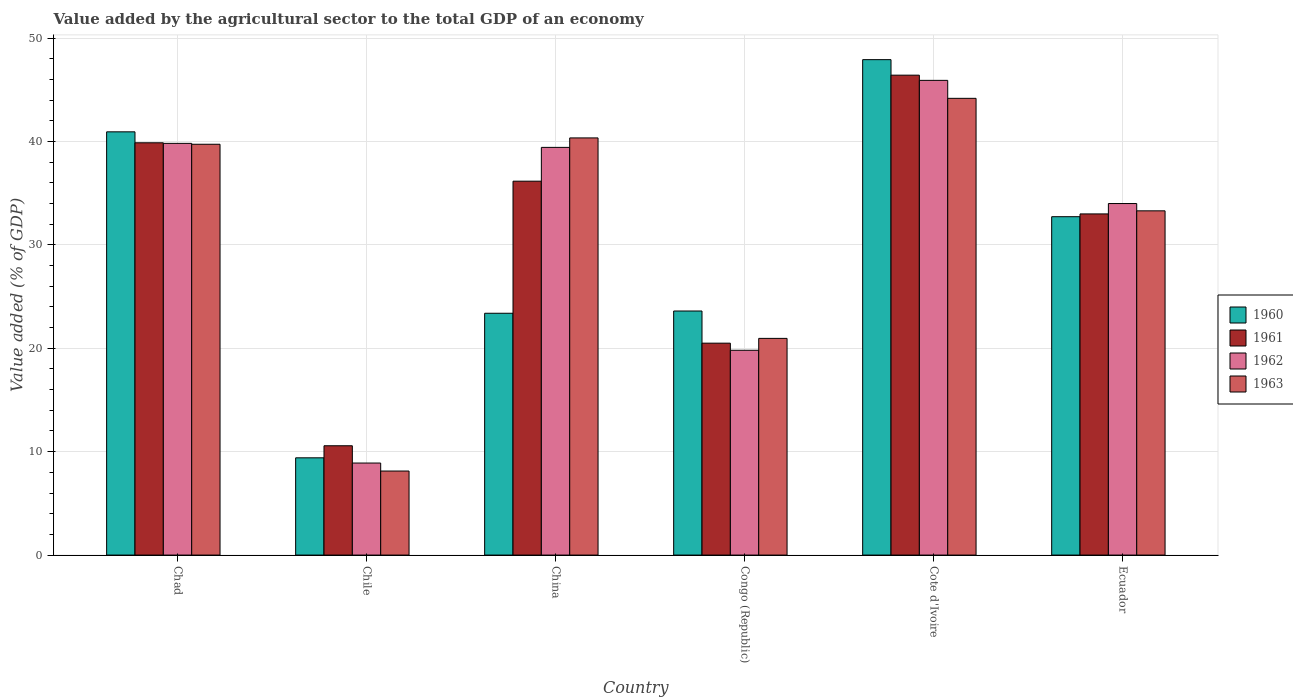How many different coloured bars are there?
Keep it short and to the point. 4. Are the number of bars on each tick of the X-axis equal?
Provide a succinct answer. Yes. How many bars are there on the 1st tick from the left?
Keep it short and to the point. 4. What is the label of the 2nd group of bars from the left?
Offer a terse response. Chile. What is the value added by the agricultural sector to the total GDP in 1963 in Chile?
Your response must be concise. 8.13. Across all countries, what is the maximum value added by the agricultural sector to the total GDP in 1962?
Keep it short and to the point. 45.9. Across all countries, what is the minimum value added by the agricultural sector to the total GDP in 1961?
Your answer should be very brief. 10.57. In which country was the value added by the agricultural sector to the total GDP in 1962 maximum?
Ensure brevity in your answer.  Cote d'Ivoire. In which country was the value added by the agricultural sector to the total GDP in 1960 minimum?
Provide a succinct answer. Chile. What is the total value added by the agricultural sector to the total GDP in 1961 in the graph?
Make the answer very short. 186.48. What is the difference between the value added by the agricultural sector to the total GDP in 1963 in China and that in Ecuador?
Provide a succinct answer. 7.05. What is the difference between the value added by the agricultural sector to the total GDP in 1962 in Chile and the value added by the agricultural sector to the total GDP in 1963 in Cote d'Ivoire?
Provide a short and direct response. -35.27. What is the average value added by the agricultural sector to the total GDP in 1960 per country?
Your answer should be very brief. 29.66. What is the difference between the value added by the agricultural sector to the total GDP of/in 1963 and value added by the agricultural sector to the total GDP of/in 1961 in Chad?
Ensure brevity in your answer.  -0.14. What is the ratio of the value added by the agricultural sector to the total GDP in 1963 in China to that in Ecuador?
Your answer should be compact. 1.21. What is the difference between the highest and the second highest value added by the agricultural sector to the total GDP in 1963?
Ensure brevity in your answer.  -3.83. What is the difference between the highest and the lowest value added by the agricultural sector to the total GDP in 1962?
Provide a succinct answer. 37. In how many countries, is the value added by the agricultural sector to the total GDP in 1963 greater than the average value added by the agricultural sector to the total GDP in 1963 taken over all countries?
Offer a terse response. 4. Is the sum of the value added by the agricultural sector to the total GDP in 1962 in Congo (Republic) and Ecuador greater than the maximum value added by the agricultural sector to the total GDP in 1961 across all countries?
Your response must be concise. Yes. Is it the case that in every country, the sum of the value added by the agricultural sector to the total GDP in 1961 and value added by the agricultural sector to the total GDP in 1960 is greater than the sum of value added by the agricultural sector to the total GDP in 1962 and value added by the agricultural sector to the total GDP in 1963?
Give a very brief answer. No. What does the 4th bar from the left in Ecuador represents?
Provide a short and direct response. 1963. What does the 4th bar from the right in Chile represents?
Ensure brevity in your answer.  1960. Is it the case that in every country, the sum of the value added by the agricultural sector to the total GDP in 1963 and value added by the agricultural sector to the total GDP in 1962 is greater than the value added by the agricultural sector to the total GDP in 1961?
Make the answer very short. Yes. How many bars are there?
Provide a short and direct response. 24. How many countries are there in the graph?
Offer a very short reply. 6. What is the difference between two consecutive major ticks on the Y-axis?
Offer a very short reply. 10. Does the graph contain grids?
Offer a very short reply. Yes. Where does the legend appear in the graph?
Offer a terse response. Center right. How many legend labels are there?
Give a very brief answer. 4. How are the legend labels stacked?
Provide a short and direct response. Vertical. What is the title of the graph?
Your answer should be very brief. Value added by the agricultural sector to the total GDP of an economy. Does "2010" appear as one of the legend labels in the graph?
Your response must be concise. No. What is the label or title of the Y-axis?
Your answer should be compact. Value added (% of GDP). What is the Value added (% of GDP) in 1960 in Chad?
Ensure brevity in your answer.  40.93. What is the Value added (% of GDP) of 1961 in Chad?
Offer a very short reply. 39.87. What is the Value added (% of GDP) of 1962 in Chad?
Provide a short and direct response. 39.81. What is the Value added (% of GDP) in 1963 in Chad?
Offer a terse response. 39.73. What is the Value added (% of GDP) in 1960 in Chile?
Provide a succinct answer. 9.4. What is the Value added (% of GDP) in 1961 in Chile?
Keep it short and to the point. 10.57. What is the Value added (% of GDP) of 1962 in Chile?
Provide a short and direct response. 8.9. What is the Value added (% of GDP) of 1963 in Chile?
Ensure brevity in your answer.  8.13. What is the Value added (% of GDP) in 1960 in China?
Ensure brevity in your answer.  23.38. What is the Value added (% of GDP) in 1961 in China?
Keep it short and to the point. 36.16. What is the Value added (% of GDP) in 1962 in China?
Provide a succinct answer. 39.42. What is the Value added (% of GDP) of 1963 in China?
Your answer should be very brief. 40.34. What is the Value added (% of GDP) in 1960 in Congo (Republic)?
Your response must be concise. 23.6. What is the Value added (% of GDP) of 1961 in Congo (Republic)?
Ensure brevity in your answer.  20.49. What is the Value added (% of GDP) of 1962 in Congo (Republic)?
Your response must be concise. 19.8. What is the Value added (% of GDP) of 1963 in Congo (Republic)?
Your response must be concise. 20.95. What is the Value added (% of GDP) of 1960 in Cote d'Ivoire?
Your answer should be compact. 47.91. What is the Value added (% of GDP) of 1961 in Cote d'Ivoire?
Keep it short and to the point. 46.41. What is the Value added (% of GDP) in 1962 in Cote d'Ivoire?
Give a very brief answer. 45.9. What is the Value added (% of GDP) of 1963 in Cote d'Ivoire?
Your answer should be very brief. 44.17. What is the Value added (% of GDP) in 1960 in Ecuador?
Provide a succinct answer. 32.72. What is the Value added (% of GDP) of 1961 in Ecuador?
Ensure brevity in your answer.  32.99. What is the Value added (% of GDP) of 1962 in Ecuador?
Give a very brief answer. 33.99. What is the Value added (% of GDP) in 1963 in Ecuador?
Your answer should be compact. 33.29. Across all countries, what is the maximum Value added (% of GDP) of 1960?
Provide a succinct answer. 47.91. Across all countries, what is the maximum Value added (% of GDP) in 1961?
Your answer should be very brief. 46.41. Across all countries, what is the maximum Value added (% of GDP) of 1962?
Your answer should be very brief. 45.9. Across all countries, what is the maximum Value added (% of GDP) of 1963?
Make the answer very short. 44.17. Across all countries, what is the minimum Value added (% of GDP) of 1960?
Offer a terse response. 9.4. Across all countries, what is the minimum Value added (% of GDP) of 1961?
Make the answer very short. 10.57. Across all countries, what is the minimum Value added (% of GDP) of 1962?
Make the answer very short. 8.9. Across all countries, what is the minimum Value added (% of GDP) in 1963?
Your answer should be compact. 8.13. What is the total Value added (% of GDP) of 1960 in the graph?
Your response must be concise. 177.94. What is the total Value added (% of GDP) of 1961 in the graph?
Your response must be concise. 186.48. What is the total Value added (% of GDP) of 1962 in the graph?
Keep it short and to the point. 187.84. What is the total Value added (% of GDP) of 1963 in the graph?
Give a very brief answer. 186.6. What is the difference between the Value added (% of GDP) in 1960 in Chad and that in Chile?
Offer a terse response. 31.52. What is the difference between the Value added (% of GDP) of 1961 in Chad and that in Chile?
Provide a short and direct response. 29.3. What is the difference between the Value added (% of GDP) in 1962 in Chad and that in Chile?
Make the answer very short. 30.91. What is the difference between the Value added (% of GDP) of 1963 in Chad and that in Chile?
Your answer should be compact. 31.6. What is the difference between the Value added (% of GDP) in 1960 in Chad and that in China?
Keep it short and to the point. 17.54. What is the difference between the Value added (% of GDP) in 1961 in Chad and that in China?
Provide a succinct answer. 3.71. What is the difference between the Value added (% of GDP) of 1962 in Chad and that in China?
Your response must be concise. 0.39. What is the difference between the Value added (% of GDP) of 1963 in Chad and that in China?
Keep it short and to the point. -0.61. What is the difference between the Value added (% of GDP) of 1960 in Chad and that in Congo (Republic)?
Offer a terse response. 17.33. What is the difference between the Value added (% of GDP) in 1961 in Chad and that in Congo (Republic)?
Your answer should be compact. 19.38. What is the difference between the Value added (% of GDP) of 1962 in Chad and that in Congo (Republic)?
Your answer should be very brief. 20.01. What is the difference between the Value added (% of GDP) of 1963 in Chad and that in Congo (Republic)?
Your response must be concise. 18.77. What is the difference between the Value added (% of GDP) in 1960 in Chad and that in Cote d'Ivoire?
Provide a succinct answer. -6.98. What is the difference between the Value added (% of GDP) in 1961 in Chad and that in Cote d'Ivoire?
Your response must be concise. -6.54. What is the difference between the Value added (% of GDP) of 1962 in Chad and that in Cote d'Ivoire?
Offer a very short reply. -6.09. What is the difference between the Value added (% of GDP) of 1963 in Chad and that in Cote d'Ivoire?
Your answer should be very brief. -4.44. What is the difference between the Value added (% of GDP) of 1960 in Chad and that in Ecuador?
Provide a succinct answer. 8.21. What is the difference between the Value added (% of GDP) in 1961 in Chad and that in Ecuador?
Offer a terse response. 6.88. What is the difference between the Value added (% of GDP) of 1962 in Chad and that in Ecuador?
Your answer should be compact. 5.82. What is the difference between the Value added (% of GDP) of 1963 in Chad and that in Ecuador?
Your response must be concise. 6.44. What is the difference between the Value added (% of GDP) in 1960 in Chile and that in China?
Make the answer very short. -13.98. What is the difference between the Value added (% of GDP) in 1961 in Chile and that in China?
Your response must be concise. -25.58. What is the difference between the Value added (% of GDP) in 1962 in Chile and that in China?
Offer a very short reply. -30.52. What is the difference between the Value added (% of GDP) in 1963 in Chile and that in China?
Provide a short and direct response. -32.21. What is the difference between the Value added (% of GDP) in 1960 in Chile and that in Congo (Republic)?
Keep it short and to the point. -14.2. What is the difference between the Value added (% of GDP) in 1961 in Chile and that in Congo (Republic)?
Keep it short and to the point. -9.92. What is the difference between the Value added (% of GDP) of 1962 in Chile and that in Congo (Republic)?
Make the answer very short. -10.91. What is the difference between the Value added (% of GDP) in 1963 in Chile and that in Congo (Republic)?
Keep it short and to the point. -12.83. What is the difference between the Value added (% of GDP) of 1960 in Chile and that in Cote d'Ivoire?
Make the answer very short. -38.5. What is the difference between the Value added (% of GDP) of 1961 in Chile and that in Cote d'Ivoire?
Offer a very short reply. -35.84. What is the difference between the Value added (% of GDP) of 1962 in Chile and that in Cote d'Ivoire?
Your response must be concise. -37. What is the difference between the Value added (% of GDP) of 1963 in Chile and that in Cote d'Ivoire?
Offer a very short reply. -36.04. What is the difference between the Value added (% of GDP) of 1960 in Chile and that in Ecuador?
Your answer should be very brief. -23.32. What is the difference between the Value added (% of GDP) in 1961 in Chile and that in Ecuador?
Ensure brevity in your answer.  -22.42. What is the difference between the Value added (% of GDP) of 1962 in Chile and that in Ecuador?
Make the answer very short. -25.09. What is the difference between the Value added (% of GDP) in 1963 in Chile and that in Ecuador?
Offer a terse response. -25.16. What is the difference between the Value added (% of GDP) in 1960 in China and that in Congo (Republic)?
Provide a succinct answer. -0.22. What is the difference between the Value added (% of GDP) of 1961 in China and that in Congo (Republic)?
Give a very brief answer. 15.66. What is the difference between the Value added (% of GDP) in 1962 in China and that in Congo (Republic)?
Ensure brevity in your answer.  19.62. What is the difference between the Value added (% of GDP) of 1963 in China and that in Congo (Republic)?
Ensure brevity in your answer.  19.38. What is the difference between the Value added (% of GDP) of 1960 in China and that in Cote d'Ivoire?
Your answer should be compact. -24.52. What is the difference between the Value added (% of GDP) of 1961 in China and that in Cote d'Ivoire?
Your answer should be very brief. -10.25. What is the difference between the Value added (% of GDP) in 1962 in China and that in Cote d'Ivoire?
Provide a succinct answer. -6.48. What is the difference between the Value added (% of GDP) of 1963 in China and that in Cote d'Ivoire?
Make the answer very short. -3.83. What is the difference between the Value added (% of GDP) in 1960 in China and that in Ecuador?
Provide a succinct answer. -9.34. What is the difference between the Value added (% of GDP) of 1961 in China and that in Ecuador?
Your response must be concise. 3.17. What is the difference between the Value added (% of GDP) of 1962 in China and that in Ecuador?
Provide a short and direct response. 5.43. What is the difference between the Value added (% of GDP) of 1963 in China and that in Ecuador?
Give a very brief answer. 7.05. What is the difference between the Value added (% of GDP) of 1960 in Congo (Republic) and that in Cote d'Ivoire?
Your response must be concise. -24.31. What is the difference between the Value added (% of GDP) in 1961 in Congo (Republic) and that in Cote d'Ivoire?
Keep it short and to the point. -25.91. What is the difference between the Value added (% of GDP) of 1962 in Congo (Republic) and that in Cote d'Ivoire?
Offer a very short reply. -26.1. What is the difference between the Value added (% of GDP) of 1963 in Congo (Republic) and that in Cote d'Ivoire?
Make the answer very short. -23.21. What is the difference between the Value added (% of GDP) in 1960 in Congo (Republic) and that in Ecuador?
Keep it short and to the point. -9.12. What is the difference between the Value added (% of GDP) in 1961 in Congo (Republic) and that in Ecuador?
Give a very brief answer. -12.5. What is the difference between the Value added (% of GDP) in 1962 in Congo (Republic) and that in Ecuador?
Make the answer very short. -14.19. What is the difference between the Value added (% of GDP) of 1963 in Congo (Republic) and that in Ecuador?
Your response must be concise. -12.33. What is the difference between the Value added (% of GDP) of 1960 in Cote d'Ivoire and that in Ecuador?
Offer a very short reply. 15.19. What is the difference between the Value added (% of GDP) in 1961 in Cote d'Ivoire and that in Ecuador?
Offer a very short reply. 13.42. What is the difference between the Value added (% of GDP) of 1962 in Cote d'Ivoire and that in Ecuador?
Make the answer very short. 11.91. What is the difference between the Value added (% of GDP) of 1963 in Cote d'Ivoire and that in Ecuador?
Make the answer very short. 10.88. What is the difference between the Value added (% of GDP) of 1960 in Chad and the Value added (% of GDP) of 1961 in Chile?
Give a very brief answer. 30.36. What is the difference between the Value added (% of GDP) of 1960 in Chad and the Value added (% of GDP) of 1962 in Chile?
Provide a short and direct response. 32.03. What is the difference between the Value added (% of GDP) of 1960 in Chad and the Value added (% of GDP) of 1963 in Chile?
Offer a very short reply. 32.8. What is the difference between the Value added (% of GDP) of 1961 in Chad and the Value added (% of GDP) of 1962 in Chile?
Offer a terse response. 30.97. What is the difference between the Value added (% of GDP) of 1961 in Chad and the Value added (% of GDP) of 1963 in Chile?
Your answer should be compact. 31.74. What is the difference between the Value added (% of GDP) in 1962 in Chad and the Value added (% of GDP) in 1963 in Chile?
Provide a short and direct response. 31.69. What is the difference between the Value added (% of GDP) of 1960 in Chad and the Value added (% of GDP) of 1961 in China?
Offer a very short reply. 4.77. What is the difference between the Value added (% of GDP) in 1960 in Chad and the Value added (% of GDP) in 1962 in China?
Give a very brief answer. 1.5. What is the difference between the Value added (% of GDP) of 1960 in Chad and the Value added (% of GDP) of 1963 in China?
Offer a terse response. 0.59. What is the difference between the Value added (% of GDP) in 1961 in Chad and the Value added (% of GDP) in 1962 in China?
Your answer should be compact. 0.44. What is the difference between the Value added (% of GDP) in 1961 in Chad and the Value added (% of GDP) in 1963 in China?
Offer a very short reply. -0.47. What is the difference between the Value added (% of GDP) of 1962 in Chad and the Value added (% of GDP) of 1963 in China?
Ensure brevity in your answer.  -0.53. What is the difference between the Value added (% of GDP) of 1960 in Chad and the Value added (% of GDP) of 1961 in Congo (Republic)?
Your answer should be compact. 20.44. What is the difference between the Value added (% of GDP) of 1960 in Chad and the Value added (% of GDP) of 1962 in Congo (Republic)?
Provide a short and direct response. 21.12. What is the difference between the Value added (% of GDP) in 1960 in Chad and the Value added (% of GDP) in 1963 in Congo (Republic)?
Provide a short and direct response. 19.97. What is the difference between the Value added (% of GDP) of 1961 in Chad and the Value added (% of GDP) of 1962 in Congo (Republic)?
Offer a very short reply. 20.06. What is the difference between the Value added (% of GDP) in 1961 in Chad and the Value added (% of GDP) in 1963 in Congo (Republic)?
Your answer should be compact. 18.91. What is the difference between the Value added (% of GDP) of 1962 in Chad and the Value added (% of GDP) of 1963 in Congo (Republic)?
Your answer should be very brief. 18.86. What is the difference between the Value added (% of GDP) in 1960 in Chad and the Value added (% of GDP) in 1961 in Cote d'Ivoire?
Your response must be concise. -5.48. What is the difference between the Value added (% of GDP) of 1960 in Chad and the Value added (% of GDP) of 1962 in Cote d'Ivoire?
Provide a short and direct response. -4.98. What is the difference between the Value added (% of GDP) of 1960 in Chad and the Value added (% of GDP) of 1963 in Cote d'Ivoire?
Ensure brevity in your answer.  -3.24. What is the difference between the Value added (% of GDP) in 1961 in Chad and the Value added (% of GDP) in 1962 in Cote d'Ivoire?
Make the answer very short. -6.04. What is the difference between the Value added (% of GDP) in 1961 in Chad and the Value added (% of GDP) in 1963 in Cote d'Ivoire?
Your response must be concise. -4.3. What is the difference between the Value added (% of GDP) of 1962 in Chad and the Value added (% of GDP) of 1963 in Cote d'Ivoire?
Give a very brief answer. -4.36. What is the difference between the Value added (% of GDP) in 1960 in Chad and the Value added (% of GDP) in 1961 in Ecuador?
Ensure brevity in your answer.  7.94. What is the difference between the Value added (% of GDP) in 1960 in Chad and the Value added (% of GDP) in 1962 in Ecuador?
Offer a very short reply. 6.93. What is the difference between the Value added (% of GDP) of 1960 in Chad and the Value added (% of GDP) of 1963 in Ecuador?
Your response must be concise. 7.64. What is the difference between the Value added (% of GDP) of 1961 in Chad and the Value added (% of GDP) of 1962 in Ecuador?
Offer a terse response. 5.87. What is the difference between the Value added (% of GDP) of 1961 in Chad and the Value added (% of GDP) of 1963 in Ecuador?
Offer a terse response. 6.58. What is the difference between the Value added (% of GDP) of 1962 in Chad and the Value added (% of GDP) of 1963 in Ecuador?
Your answer should be compact. 6.52. What is the difference between the Value added (% of GDP) of 1960 in Chile and the Value added (% of GDP) of 1961 in China?
Offer a very short reply. -26.75. What is the difference between the Value added (% of GDP) of 1960 in Chile and the Value added (% of GDP) of 1962 in China?
Provide a short and direct response. -30.02. What is the difference between the Value added (% of GDP) in 1960 in Chile and the Value added (% of GDP) in 1963 in China?
Keep it short and to the point. -30.93. What is the difference between the Value added (% of GDP) in 1961 in Chile and the Value added (% of GDP) in 1962 in China?
Give a very brief answer. -28.85. What is the difference between the Value added (% of GDP) in 1961 in Chile and the Value added (% of GDP) in 1963 in China?
Provide a succinct answer. -29.77. What is the difference between the Value added (% of GDP) in 1962 in Chile and the Value added (% of GDP) in 1963 in China?
Keep it short and to the point. -31.44. What is the difference between the Value added (% of GDP) in 1960 in Chile and the Value added (% of GDP) in 1961 in Congo (Republic)?
Ensure brevity in your answer.  -11.09. What is the difference between the Value added (% of GDP) of 1960 in Chile and the Value added (% of GDP) of 1962 in Congo (Republic)?
Offer a terse response. -10.4. What is the difference between the Value added (% of GDP) of 1960 in Chile and the Value added (% of GDP) of 1963 in Congo (Republic)?
Ensure brevity in your answer.  -11.55. What is the difference between the Value added (% of GDP) in 1961 in Chile and the Value added (% of GDP) in 1962 in Congo (Republic)?
Offer a very short reply. -9.23. What is the difference between the Value added (% of GDP) of 1961 in Chile and the Value added (% of GDP) of 1963 in Congo (Republic)?
Provide a succinct answer. -10.38. What is the difference between the Value added (% of GDP) in 1962 in Chile and the Value added (% of GDP) in 1963 in Congo (Republic)?
Your response must be concise. -12.05. What is the difference between the Value added (% of GDP) in 1960 in Chile and the Value added (% of GDP) in 1961 in Cote d'Ivoire?
Your response must be concise. -37. What is the difference between the Value added (% of GDP) in 1960 in Chile and the Value added (% of GDP) in 1962 in Cote d'Ivoire?
Ensure brevity in your answer.  -36.5. What is the difference between the Value added (% of GDP) in 1960 in Chile and the Value added (% of GDP) in 1963 in Cote d'Ivoire?
Your response must be concise. -34.76. What is the difference between the Value added (% of GDP) of 1961 in Chile and the Value added (% of GDP) of 1962 in Cote d'Ivoire?
Provide a short and direct response. -35.33. What is the difference between the Value added (% of GDP) of 1961 in Chile and the Value added (% of GDP) of 1963 in Cote d'Ivoire?
Give a very brief answer. -33.6. What is the difference between the Value added (% of GDP) in 1962 in Chile and the Value added (% of GDP) in 1963 in Cote d'Ivoire?
Ensure brevity in your answer.  -35.27. What is the difference between the Value added (% of GDP) of 1960 in Chile and the Value added (% of GDP) of 1961 in Ecuador?
Your response must be concise. -23.59. What is the difference between the Value added (% of GDP) in 1960 in Chile and the Value added (% of GDP) in 1962 in Ecuador?
Your answer should be compact. -24.59. What is the difference between the Value added (% of GDP) in 1960 in Chile and the Value added (% of GDP) in 1963 in Ecuador?
Keep it short and to the point. -23.88. What is the difference between the Value added (% of GDP) of 1961 in Chile and the Value added (% of GDP) of 1962 in Ecuador?
Keep it short and to the point. -23.42. What is the difference between the Value added (% of GDP) of 1961 in Chile and the Value added (% of GDP) of 1963 in Ecuador?
Make the answer very short. -22.72. What is the difference between the Value added (% of GDP) in 1962 in Chile and the Value added (% of GDP) in 1963 in Ecuador?
Your answer should be very brief. -24.39. What is the difference between the Value added (% of GDP) in 1960 in China and the Value added (% of GDP) in 1961 in Congo (Republic)?
Ensure brevity in your answer.  2.89. What is the difference between the Value added (% of GDP) in 1960 in China and the Value added (% of GDP) in 1962 in Congo (Republic)?
Give a very brief answer. 3.58. What is the difference between the Value added (% of GDP) of 1960 in China and the Value added (% of GDP) of 1963 in Congo (Republic)?
Provide a short and direct response. 2.43. What is the difference between the Value added (% of GDP) in 1961 in China and the Value added (% of GDP) in 1962 in Congo (Republic)?
Keep it short and to the point. 16.35. What is the difference between the Value added (% of GDP) of 1961 in China and the Value added (% of GDP) of 1963 in Congo (Republic)?
Provide a succinct answer. 15.2. What is the difference between the Value added (% of GDP) of 1962 in China and the Value added (% of GDP) of 1963 in Congo (Republic)?
Provide a succinct answer. 18.47. What is the difference between the Value added (% of GDP) in 1960 in China and the Value added (% of GDP) in 1961 in Cote d'Ivoire?
Provide a short and direct response. -23.02. What is the difference between the Value added (% of GDP) of 1960 in China and the Value added (% of GDP) of 1962 in Cote d'Ivoire?
Offer a terse response. -22.52. What is the difference between the Value added (% of GDP) in 1960 in China and the Value added (% of GDP) in 1963 in Cote d'Ivoire?
Offer a terse response. -20.78. What is the difference between the Value added (% of GDP) in 1961 in China and the Value added (% of GDP) in 1962 in Cote d'Ivoire?
Make the answer very short. -9.75. What is the difference between the Value added (% of GDP) of 1961 in China and the Value added (% of GDP) of 1963 in Cote d'Ivoire?
Your answer should be compact. -8.01. What is the difference between the Value added (% of GDP) of 1962 in China and the Value added (% of GDP) of 1963 in Cote d'Ivoire?
Provide a short and direct response. -4.74. What is the difference between the Value added (% of GDP) of 1960 in China and the Value added (% of GDP) of 1961 in Ecuador?
Give a very brief answer. -9.61. What is the difference between the Value added (% of GDP) of 1960 in China and the Value added (% of GDP) of 1962 in Ecuador?
Make the answer very short. -10.61. What is the difference between the Value added (% of GDP) of 1960 in China and the Value added (% of GDP) of 1963 in Ecuador?
Offer a very short reply. -9.9. What is the difference between the Value added (% of GDP) in 1961 in China and the Value added (% of GDP) in 1962 in Ecuador?
Provide a short and direct response. 2.16. What is the difference between the Value added (% of GDP) of 1961 in China and the Value added (% of GDP) of 1963 in Ecuador?
Offer a very short reply. 2.87. What is the difference between the Value added (% of GDP) in 1962 in China and the Value added (% of GDP) in 1963 in Ecuador?
Offer a terse response. 6.14. What is the difference between the Value added (% of GDP) in 1960 in Congo (Republic) and the Value added (% of GDP) in 1961 in Cote d'Ivoire?
Provide a short and direct response. -22.81. What is the difference between the Value added (% of GDP) in 1960 in Congo (Republic) and the Value added (% of GDP) in 1962 in Cote d'Ivoire?
Provide a short and direct response. -22.3. What is the difference between the Value added (% of GDP) in 1960 in Congo (Republic) and the Value added (% of GDP) in 1963 in Cote d'Ivoire?
Offer a very short reply. -20.57. What is the difference between the Value added (% of GDP) in 1961 in Congo (Republic) and the Value added (% of GDP) in 1962 in Cote d'Ivoire?
Give a very brief answer. -25.41. What is the difference between the Value added (% of GDP) of 1961 in Congo (Republic) and the Value added (% of GDP) of 1963 in Cote d'Ivoire?
Give a very brief answer. -23.68. What is the difference between the Value added (% of GDP) in 1962 in Congo (Republic) and the Value added (% of GDP) in 1963 in Cote d'Ivoire?
Give a very brief answer. -24.36. What is the difference between the Value added (% of GDP) in 1960 in Congo (Republic) and the Value added (% of GDP) in 1961 in Ecuador?
Give a very brief answer. -9.39. What is the difference between the Value added (% of GDP) in 1960 in Congo (Republic) and the Value added (% of GDP) in 1962 in Ecuador?
Your answer should be very brief. -10.39. What is the difference between the Value added (% of GDP) in 1960 in Congo (Republic) and the Value added (% of GDP) in 1963 in Ecuador?
Your response must be concise. -9.69. What is the difference between the Value added (% of GDP) of 1961 in Congo (Republic) and the Value added (% of GDP) of 1962 in Ecuador?
Give a very brief answer. -13.5. What is the difference between the Value added (% of GDP) in 1961 in Congo (Republic) and the Value added (% of GDP) in 1963 in Ecuador?
Offer a very short reply. -12.8. What is the difference between the Value added (% of GDP) of 1962 in Congo (Republic) and the Value added (% of GDP) of 1963 in Ecuador?
Provide a succinct answer. -13.48. What is the difference between the Value added (% of GDP) in 1960 in Cote d'Ivoire and the Value added (% of GDP) in 1961 in Ecuador?
Your answer should be very brief. 14.92. What is the difference between the Value added (% of GDP) in 1960 in Cote d'Ivoire and the Value added (% of GDP) in 1962 in Ecuador?
Give a very brief answer. 13.91. What is the difference between the Value added (% of GDP) of 1960 in Cote d'Ivoire and the Value added (% of GDP) of 1963 in Ecuador?
Your answer should be very brief. 14.62. What is the difference between the Value added (% of GDP) in 1961 in Cote d'Ivoire and the Value added (% of GDP) in 1962 in Ecuador?
Keep it short and to the point. 12.41. What is the difference between the Value added (% of GDP) of 1961 in Cote d'Ivoire and the Value added (% of GDP) of 1963 in Ecuador?
Provide a succinct answer. 13.12. What is the difference between the Value added (% of GDP) of 1962 in Cote d'Ivoire and the Value added (% of GDP) of 1963 in Ecuador?
Provide a short and direct response. 12.62. What is the average Value added (% of GDP) in 1960 per country?
Your response must be concise. 29.66. What is the average Value added (% of GDP) in 1961 per country?
Your response must be concise. 31.08. What is the average Value added (% of GDP) in 1962 per country?
Provide a succinct answer. 31.31. What is the average Value added (% of GDP) of 1963 per country?
Your answer should be compact. 31.1. What is the difference between the Value added (% of GDP) of 1960 and Value added (% of GDP) of 1961 in Chad?
Your answer should be compact. 1.06. What is the difference between the Value added (% of GDP) of 1960 and Value added (% of GDP) of 1962 in Chad?
Your response must be concise. 1.11. What is the difference between the Value added (% of GDP) of 1960 and Value added (% of GDP) of 1963 in Chad?
Your response must be concise. 1.2. What is the difference between the Value added (% of GDP) of 1961 and Value added (% of GDP) of 1962 in Chad?
Your answer should be very brief. 0.06. What is the difference between the Value added (% of GDP) in 1961 and Value added (% of GDP) in 1963 in Chad?
Give a very brief answer. 0.14. What is the difference between the Value added (% of GDP) of 1962 and Value added (% of GDP) of 1963 in Chad?
Ensure brevity in your answer.  0.09. What is the difference between the Value added (% of GDP) of 1960 and Value added (% of GDP) of 1961 in Chile?
Make the answer very short. -1.17. What is the difference between the Value added (% of GDP) in 1960 and Value added (% of GDP) in 1962 in Chile?
Offer a very short reply. 0.51. What is the difference between the Value added (% of GDP) in 1960 and Value added (% of GDP) in 1963 in Chile?
Provide a short and direct response. 1.28. What is the difference between the Value added (% of GDP) of 1961 and Value added (% of GDP) of 1962 in Chile?
Provide a succinct answer. 1.67. What is the difference between the Value added (% of GDP) in 1961 and Value added (% of GDP) in 1963 in Chile?
Provide a succinct answer. 2.45. What is the difference between the Value added (% of GDP) in 1962 and Value added (% of GDP) in 1963 in Chile?
Provide a short and direct response. 0.77. What is the difference between the Value added (% of GDP) of 1960 and Value added (% of GDP) of 1961 in China?
Offer a terse response. -12.77. What is the difference between the Value added (% of GDP) in 1960 and Value added (% of GDP) in 1962 in China?
Give a very brief answer. -16.04. What is the difference between the Value added (% of GDP) of 1960 and Value added (% of GDP) of 1963 in China?
Your answer should be very brief. -16.96. What is the difference between the Value added (% of GDP) in 1961 and Value added (% of GDP) in 1962 in China?
Your answer should be compact. -3.27. What is the difference between the Value added (% of GDP) of 1961 and Value added (% of GDP) of 1963 in China?
Keep it short and to the point. -4.18. What is the difference between the Value added (% of GDP) in 1962 and Value added (% of GDP) in 1963 in China?
Your answer should be compact. -0.91. What is the difference between the Value added (% of GDP) in 1960 and Value added (% of GDP) in 1961 in Congo (Republic)?
Make the answer very short. 3.11. What is the difference between the Value added (% of GDP) in 1960 and Value added (% of GDP) in 1962 in Congo (Republic)?
Your answer should be very brief. 3.8. What is the difference between the Value added (% of GDP) of 1960 and Value added (% of GDP) of 1963 in Congo (Republic)?
Ensure brevity in your answer.  2.65. What is the difference between the Value added (% of GDP) of 1961 and Value added (% of GDP) of 1962 in Congo (Republic)?
Offer a terse response. 0.69. What is the difference between the Value added (% of GDP) of 1961 and Value added (% of GDP) of 1963 in Congo (Republic)?
Make the answer very short. -0.46. What is the difference between the Value added (% of GDP) in 1962 and Value added (% of GDP) in 1963 in Congo (Republic)?
Offer a terse response. -1.15. What is the difference between the Value added (% of GDP) in 1960 and Value added (% of GDP) in 1961 in Cote d'Ivoire?
Ensure brevity in your answer.  1.5. What is the difference between the Value added (% of GDP) of 1960 and Value added (% of GDP) of 1962 in Cote d'Ivoire?
Your answer should be compact. 2. What is the difference between the Value added (% of GDP) of 1960 and Value added (% of GDP) of 1963 in Cote d'Ivoire?
Keep it short and to the point. 3.74. What is the difference between the Value added (% of GDP) in 1961 and Value added (% of GDP) in 1962 in Cote d'Ivoire?
Ensure brevity in your answer.  0.5. What is the difference between the Value added (% of GDP) in 1961 and Value added (% of GDP) in 1963 in Cote d'Ivoire?
Ensure brevity in your answer.  2.24. What is the difference between the Value added (% of GDP) in 1962 and Value added (% of GDP) in 1963 in Cote d'Ivoire?
Offer a terse response. 1.74. What is the difference between the Value added (% of GDP) in 1960 and Value added (% of GDP) in 1961 in Ecuador?
Keep it short and to the point. -0.27. What is the difference between the Value added (% of GDP) in 1960 and Value added (% of GDP) in 1962 in Ecuador?
Provide a succinct answer. -1.27. What is the difference between the Value added (% of GDP) of 1960 and Value added (% of GDP) of 1963 in Ecuador?
Keep it short and to the point. -0.57. What is the difference between the Value added (% of GDP) of 1961 and Value added (% of GDP) of 1962 in Ecuador?
Provide a succinct answer. -1. What is the difference between the Value added (% of GDP) in 1961 and Value added (% of GDP) in 1963 in Ecuador?
Offer a very short reply. -0.3. What is the difference between the Value added (% of GDP) of 1962 and Value added (% of GDP) of 1963 in Ecuador?
Offer a very short reply. 0.71. What is the ratio of the Value added (% of GDP) of 1960 in Chad to that in Chile?
Offer a terse response. 4.35. What is the ratio of the Value added (% of GDP) in 1961 in Chad to that in Chile?
Give a very brief answer. 3.77. What is the ratio of the Value added (% of GDP) of 1962 in Chad to that in Chile?
Make the answer very short. 4.47. What is the ratio of the Value added (% of GDP) of 1963 in Chad to that in Chile?
Your response must be concise. 4.89. What is the ratio of the Value added (% of GDP) in 1960 in Chad to that in China?
Provide a short and direct response. 1.75. What is the ratio of the Value added (% of GDP) in 1961 in Chad to that in China?
Provide a succinct answer. 1.1. What is the ratio of the Value added (% of GDP) of 1962 in Chad to that in China?
Offer a terse response. 1.01. What is the ratio of the Value added (% of GDP) of 1963 in Chad to that in China?
Provide a succinct answer. 0.98. What is the ratio of the Value added (% of GDP) of 1960 in Chad to that in Congo (Republic)?
Your answer should be very brief. 1.73. What is the ratio of the Value added (% of GDP) of 1961 in Chad to that in Congo (Republic)?
Your answer should be compact. 1.95. What is the ratio of the Value added (% of GDP) of 1962 in Chad to that in Congo (Republic)?
Offer a very short reply. 2.01. What is the ratio of the Value added (% of GDP) in 1963 in Chad to that in Congo (Republic)?
Your answer should be compact. 1.9. What is the ratio of the Value added (% of GDP) of 1960 in Chad to that in Cote d'Ivoire?
Your answer should be very brief. 0.85. What is the ratio of the Value added (% of GDP) of 1961 in Chad to that in Cote d'Ivoire?
Ensure brevity in your answer.  0.86. What is the ratio of the Value added (% of GDP) in 1962 in Chad to that in Cote d'Ivoire?
Give a very brief answer. 0.87. What is the ratio of the Value added (% of GDP) of 1963 in Chad to that in Cote d'Ivoire?
Offer a very short reply. 0.9. What is the ratio of the Value added (% of GDP) in 1960 in Chad to that in Ecuador?
Offer a very short reply. 1.25. What is the ratio of the Value added (% of GDP) of 1961 in Chad to that in Ecuador?
Keep it short and to the point. 1.21. What is the ratio of the Value added (% of GDP) of 1962 in Chad to that in Ecuador?
Your answer should be compact. 1.17. What is the ratio of the Value added (% of GDP) in 1963 in Chad to that in Ecuador?
Offer a very short reply. 1.19. What is the ratio of the Value added (% of GDP) in 1960 in Chile to that in China?
Ensure brevity in your answer.  0.4. What is the ratio of the Value added (% of GDP) of 1961 in Chile to that in China?
Make the answer very short. 0.29. What is the ratio of the Value added (% of GDP) of 1962 in Chile to that in China?
Keep it short and to the point. 0.23. What is the ratio of the Value added (% of GDP) in 1963 in Chile to that in China?
Ensure brevity in your answer.  0.2. What is the ratio of the Value added (% of GDP) in 1960 in Chile to that in Congo (Republic)?
Offer a very short reply. 0.4. What is the ratio of the Value added (% of GDP) in 1961 in Chile to that in Congo (Republic)?
Provide a short and direct response. 0.52. What is the ratio of the Value added (% of GDP) in 1962 in Chile to that in Congo (Republic)?
Provide a succinct answer. 0.45. What is the ratio of the Value added (% of GDP) of 1963 in Chile to that in Congo (Republic)?
Offer a terse response. 0.39. What is the ratio of the Value added (% of GDP) in 1960 in Chile to that in Cote d'Ivoire?
Your answer should be compact. 0.2. What is the ratio of the Value added (% of GDP) of 1961 in Chile to that in Cote d'Ivoire?
Your answer should be very brief. 0.23. What is the ratio of the Value added (% of GDP) in 1962 in Chile to that in Cote d'Ivoire?
Provide a succinct answer. 0.19. What is the ratio of the Value added (% of GDP) in 1963 in Chile to that in Cote d'Ivoire?
Offer a terse response. 0.18. What is the ratio of the Value added (% of GDP) of 1960 in Chile to that in Ecuador?
Offer a very short reply. 0.29. What is the ratio of the Value added (% of GDP) in 1961 in Chile to that in Ecuador?
Give a very brief answer. 0.32. What is the ratio of the Value added (% of GDP) in 1962 in Chile to that in Ecuador?
Keep it short and to the point. 0.26. What is the ratio of the Value added (% of GDP) in 1963 in Chile to that in Ecuador?
Your response must be concise. 0.24. What is the ratio of the Value added (% of GDP) in 1961 in China to that in Congo (Republic)?
Provide a succinct answer. 1.76. What is the ratio of the Value added (% of GDP) of 1962 in China to that in Congo (Republic)?
Provide a succinct answer. 1.99. What is the ratio of the Value added (% of GDP) of 1963 in China to that in Congo (Republic)?
Provide a succinct answer. 1.93. What is the ratio of the Value added (% of GDP) of 1960 in China to that in Cote d'Ivoire?
Offer a terse response. 0.49. What is the ratio of the Value added (% of GDP) in 1961 in China to that in Cote d'Ivoire?
Provide a succinct answer. 0.78. What is the ratio of the Value added (% of GDP) of 1962 in China to that in Cote d'Ivoire?
Offer a very short reply. 0.86. What is the ratio of the Value added (% of GDP) in 1963 in China to that in Cote d'Ivoire?
Provide a succinct answer. 0.91. What is the ratio of the Value added (% of GDP) in 1960 in China to that in Ecuador?
Make the answer very short. 0.71. What is the ratio of the Value added (% of GDP) of 1961 in China to that in Ecuador?
Your response must be concise. 1.1. What is the ratio of the Value added (% of GDP) in 1962 in China to that in Ecuador?
Provide a short and direct response. 1.16. What is the ratio of the Value added (% of GDP) in 1963 in China to that in Ecuador?
Provide a succinct answer. 1.21. What is the ratio of the Value added (% of GDP) in 1960 in Congo (Republic) to that in Cote d'Ivoire?
Your answer should be compact. 0.49. What is the ratio of the Value added (% of GDP) in 1961 in Congo (Republic) to that in Cote d'Ivoire?
Keep it short and to the point. 0.44. What is the ratio of the Value added (% of GDP) of 1962 in Congo (Republic) to that in Cote d'Ivoire?
Provide a short and direct response. 0.43. What is the ratio of the Value added (% of GDP) of 1963 in Congo (Republic) to that in Cote d'Ivoire?
Make the answer very short. 0.47. What is the ratio of the Value added (% of GDP) in 1960 in Congo (Republic) to that in Ecuador?
Ensure brevity in your answer.  0.72. What is the ratio of the Value added (% of GDP) in 1961 in Congo (Republic) to that in Ecuador?
Offer a terse response. 0.62. What is the ratio of the Value added (% of GDP) of 1962 in Congo (Republic) to that in Ecuador?
Make the answer very short. 0.58. What is the ratio of the Value added (% of GDP) of 1963 in Congo (Republic) to that in Ecuador?
Offer a terse response. 0.63. What is the ratio of the Value added (% of GDP) in 1960 in Cote d'Ivoire to that in Ecuador?
Offer a terse response. 1.46. What is the ratio of the Value added (% of GDP) in 1961 in Cote d'Ivoire to that in Ecuador?
Your answer should be compact. 1.41. What is the ratio of the Value added (% of GDP) of 1962 in Cote d'Ivoire to that in Ecuador?
Your answer should be compact. 1.35. What is the ratio of the Value added (% of GDP) of 1963 in Cote d'Ivoire to that in Ecuador?
Your response must be concise. 1.33. What is the difference between the highest and the second highest Value added (% of GDP) of 1960?
Your answer should be compact. 6.98. What is the difference between the highest and the second highest Value added (% of GDP) in 1961?
Your answer should be very brief. 6.54. What is the difference between the highest and the second highest Value added (% of GDP) of 1962?
Provide a short and direct response. 6.09. What is the difference between the highest and the second highest Value added (% of GDP) in 1963?
Your answer should be compact. 3.83. What is the difference between the highest and the lowest Value added (% of GDP) in 1960?
Give a very brief answer. 38.5. What is the difference between the highest and the lowest Value added (% of GDP) in 1961?
Provide a succinct answer. 35.84. What is the difference between the highest and the lowest Value added (% of GDP) of 1962?
Your answer should be very brief. 37. What is the difference between the highest and the lowest Value added (% of GDP) in 1963?
Your answer should be very brief. 36.04. 